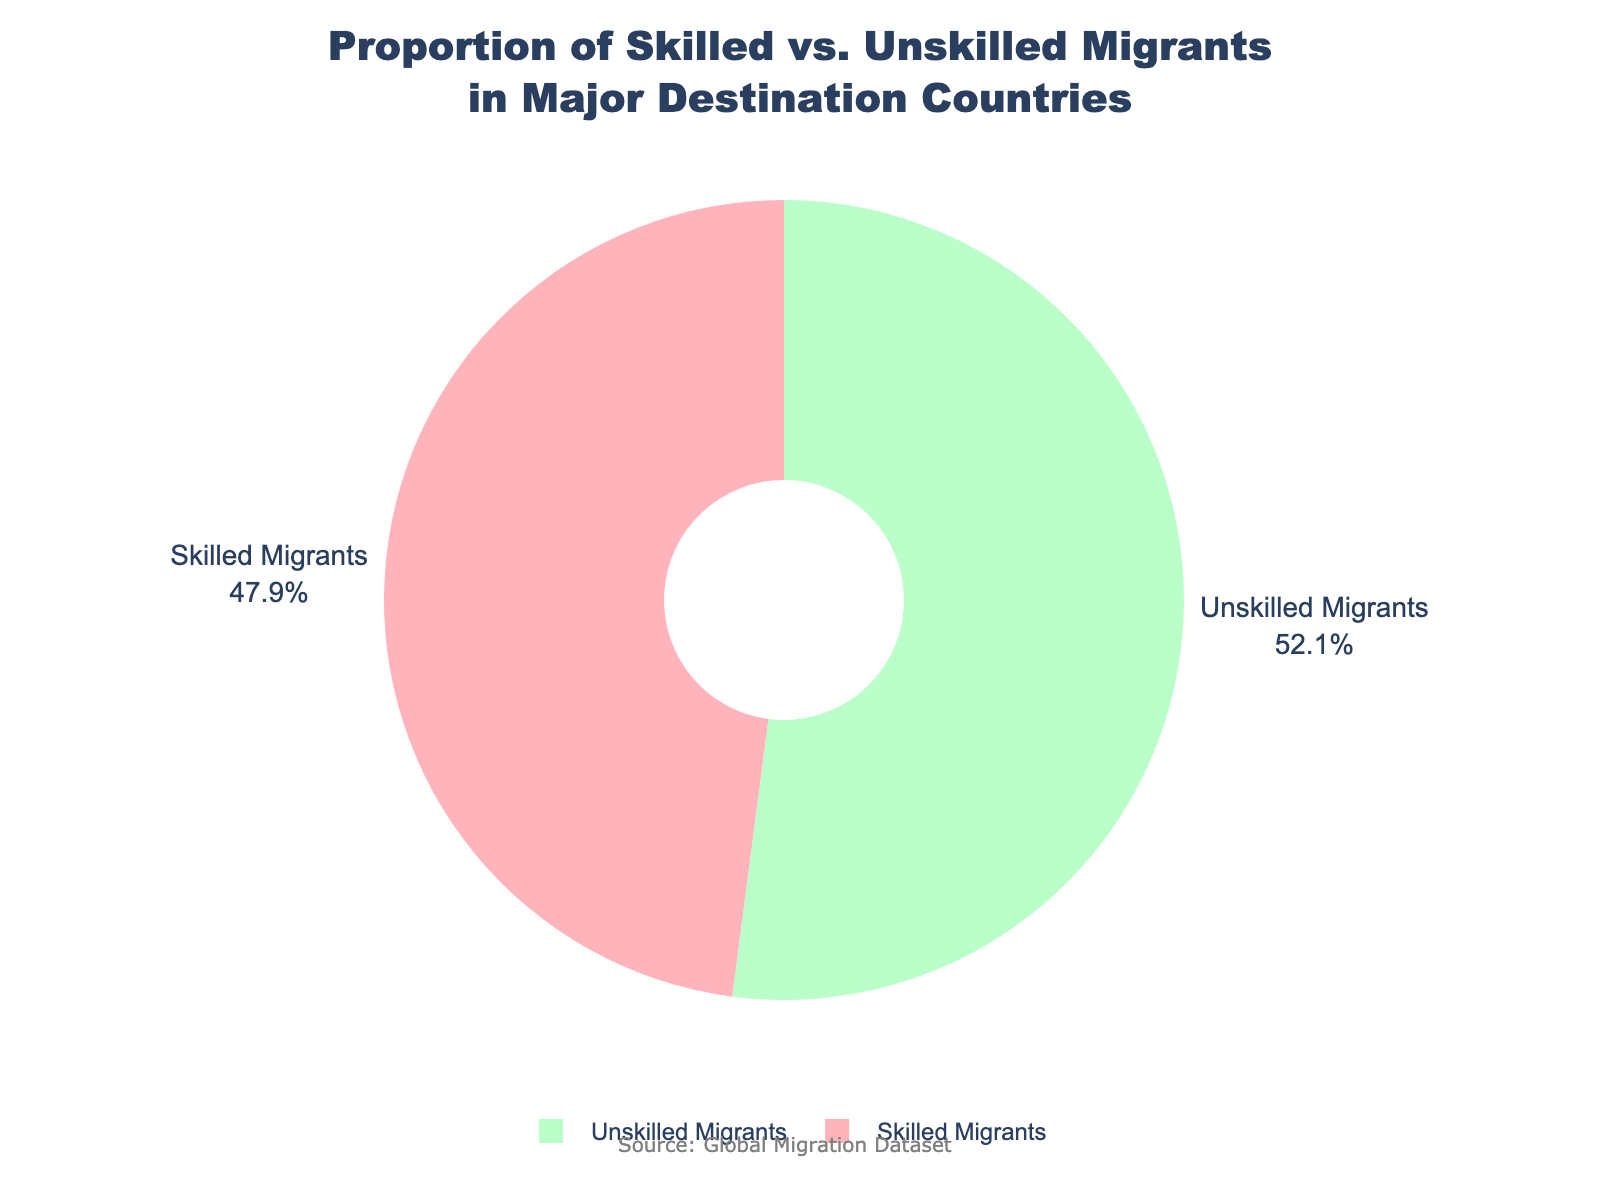What is the percentage of unskilled migrants in major destination countries? The pie chart shows that the unskilled migrants account for 52.8% of the total migrant population in major destination countries.
Answer: 52.8% Which group has a higher proportion of the total migrants, skilled or unskilled? The pie chart shows two sectors: one representing skilled migrants and another representing unskilled migrants. The unskilled migrants' sector is larger, indicating that there are more unskilled migrants.
Answer: Unskilled migrants What color is used to represent skilled migrants? The pie chart uses a specific color for each category. The sector representing skilled migrants is colored pink.
Answer: Pink What is the difference in percentage between skilled and unskilled migrants? From the pie chart, the percentage of skilled migrants is 47.2% and unskilled migrants is 52.8%. The difference can be calculated as 52.8% - 47.2% = 5.6%.
Answer: 5.6% Is there an equal proportion of skilled and unskilled migrants? The pie chart provides the exact proportions for each category. Since the skilled migrants constitute 47.2% and unskilled migrants 52.8%, the proportions are not equal.
Answer: No What is the sum of the percentages of skilled and unskilled migrants? The sum of the percentages of skilled and unskilled migrants is given by adding the percentages. Thus, 47.2% (skilled) + 52.8% (unskilled) = 100%.
Answer: 100% Which segment is larger, the one representing skilled migrants or unskilled migrants? By observing the size of the segments in the pie chart, it is clear that the unskilled migrants' segment is larger than the skilled migrants' segment.
Answer: Unskilled migrants How much larger is the unskilled migrant group compared to the skilled migrant group? The percentage of unskilled migrants is 52.8% while that of skilled migrants is 47.2%. The difference is 52.8% - 47.2% = 5.6% showing how much larger the unskilled group is.
Answer: 5.6% What does the annotation at the bottom of the figure state? The annotation at the bottom of the figure provides the source of the data. It states "Source: Global Migration Dataset".
Answer: Source: Global Migration Dataset 